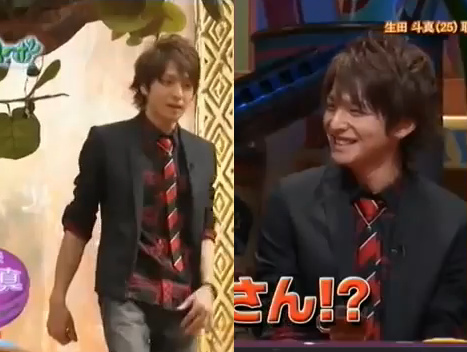Do the necktie and the shirt have the sharegpt4v/same color? Yes, the necktie and the shirt are the sharegpt4v/same color. 